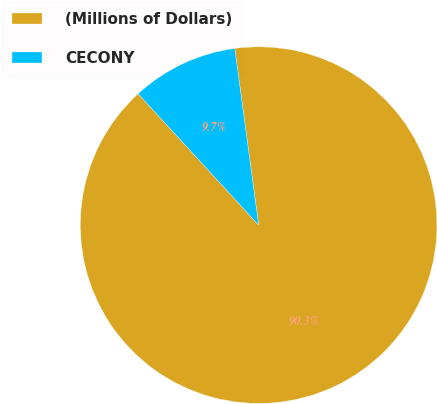Convert chart. <chart><loc_0><loc_0><loc_500><loc_500><pie_chart><fcel>(Millions of Dollars)<fcel>CECONY<nl><fcel>90.32%<fcel>9.68%<nl></chart> 